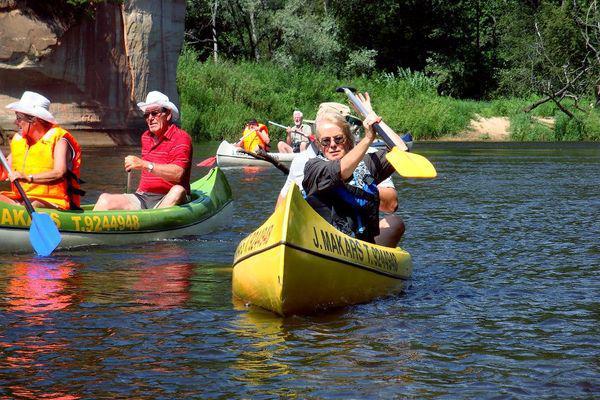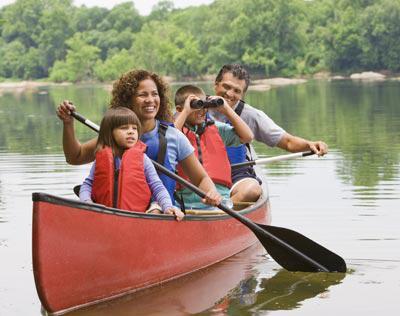The first image is the image on the left, the second image is the image on the right. Considering the images on both sides, is "The left image includes a canoe in the foreground heading away from the camera, and the right image shows at least one forward moving kayak-type boat." valid? Answer yes or no. No. The first image is the image on the left, the second image is the image on the right. Considering the images on both sides, is "In the image on the right, four people are riding in one canoe." valid? Answer yes or no. Yes. 